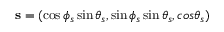<formula> <loc_0><loc_0><loc_500><loc_500>{ s } = ( \cos \phi _ { s } \sin \theta _ { s } , \sin \phi _ { s } \sin \theta _ { s } , \cos \theta _ { s } )</formula> 